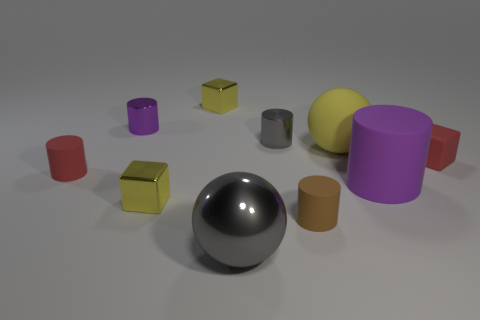Subtract all shiny cylinders. How many cylinders are left? 3 Subtract all red cylinders. How many yellow blocks are left? 2 Subtract 2 cubes. How many cubes are left? 1 Subtract all red blocks. How many blocks are left? 2 Subtract all blocks. How many objects are left? 7 Subtract all large red things. Subtract all yellow things. How many objects are left? 7 Add 9 large metal objects. How many large metal objects are left? 10 Add 5 brown cylinders. How many brown cylinders exist? 6 Subtract 0 purple spheres. How many objects are left? 10 Subtract all yellow blocks. Subtract all brown cylinders. How many blocks are left? 1 